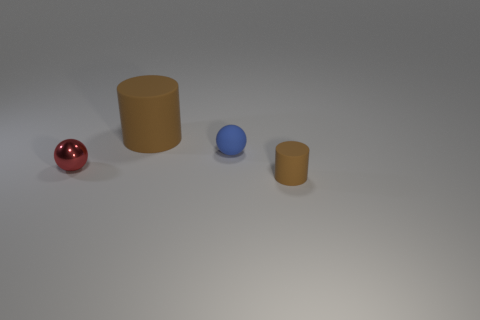There is a rubber object that is the same color as the large cylinder; what shape is it?
Your answer should be very brief. Cylinder. There is a metal sphere; how many spheres are behind it?
Your answer should be compact. 1. There is another rubber cylinder that is the same color as the small rubber cylinder; what is its size?
Your response must be concise. Large. Is there a big brown matte object that has the same shape as the small red object?
Keep it short and to the point. No. There is a matte cylinder that is the same size as the matte sphere; what color is it?
Your response must be concise. Brown. Is the number of tiny metal spheres behind the small red thing less than the number of tiny metallic balls that are in front of the big cylinder?
Offer a terse response. Yes. There is a brown rubber cylinder in front of the blue matte sphere; is its size the same as the large brown matte cylinder?
Your response must be concise. No. What is the shape of the thing that is behind the blue thing?
Ensure brevity in your answer.  Cylinder. Are there more blue balls than brown cylinders?
Your answer should be very brief. No. There is a rubber cylinder behind the small cylinder; is its color the same as the metal object?
Make the answer very short. No. 